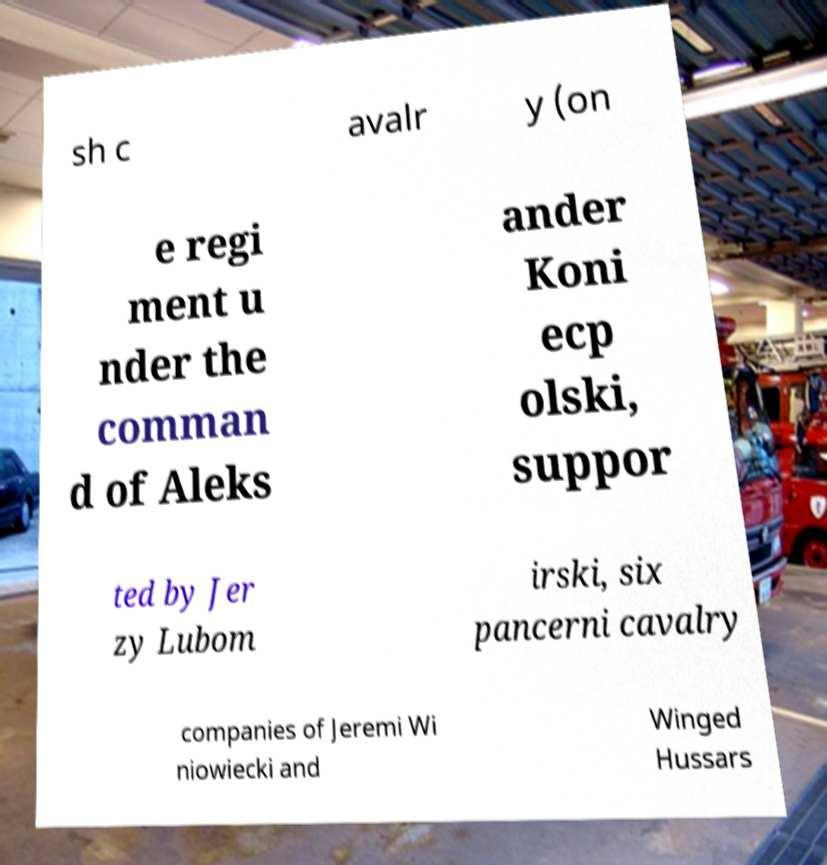Could you extract and type out the text from this image? sh c avalr y (on e regi ment u nder the comman d of Aleks ander Koni ecp olski, suppor ted by Jer zy Lubom irski, six pancerni cavalry companies of Jeremi Wi niowiecki and Winged Hussars 